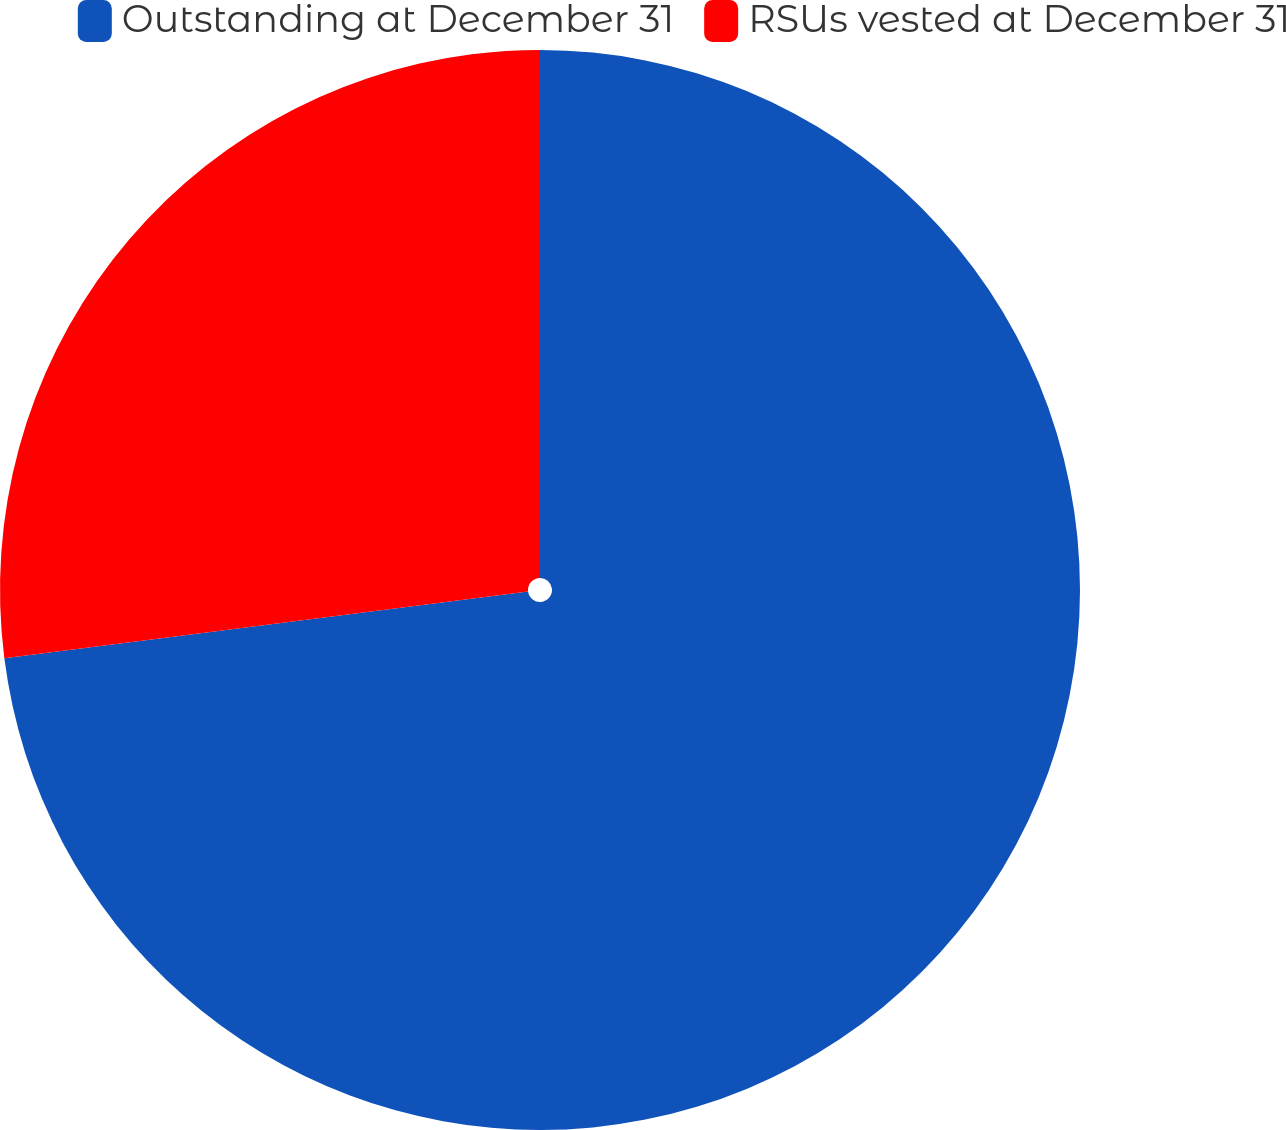<chart> <loc_0><loc_0><loc_500><loc_500><pie_chart><fcel>Outstanding at December 31<fcel>RSUs vested at December 31<nl><fcel>72.98%<fcel>27.02%<nl></chart> 